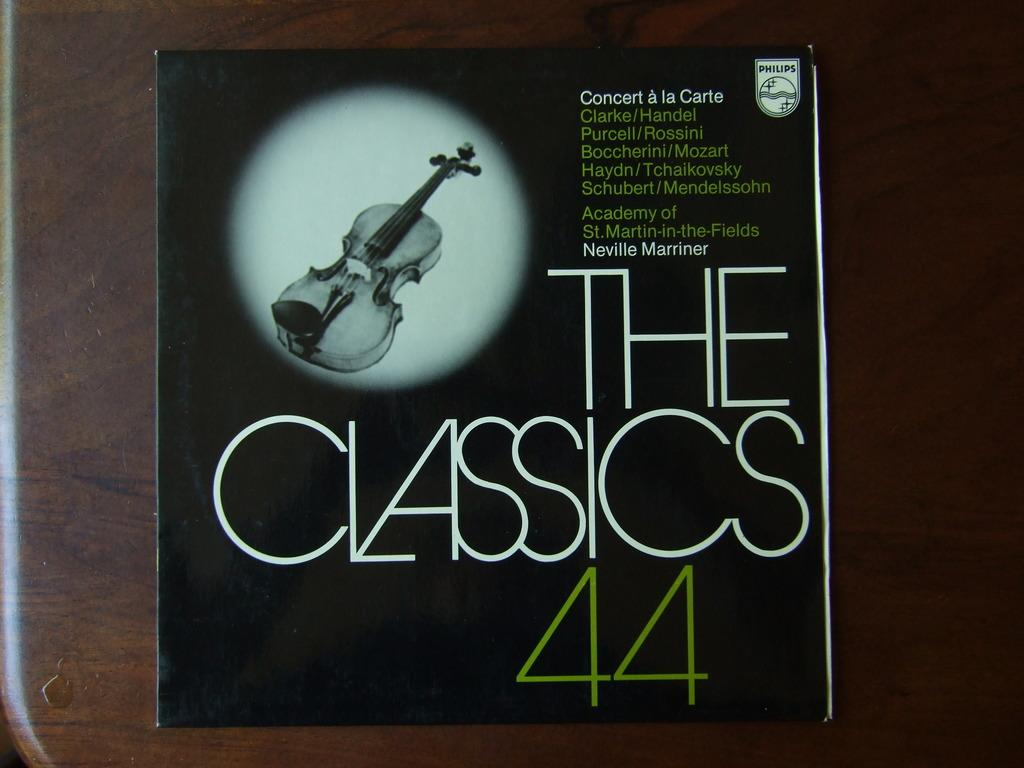What is the main object in the center of the image? There is a book in the center of the image. What can be seen on the book? The book has text written on it. Where is the book located? The book is on a table. What thrill does the book provide in the image? The image does not convey any sense of thrill or excitement related to the book. The book is simply present on a table with text written on it. 